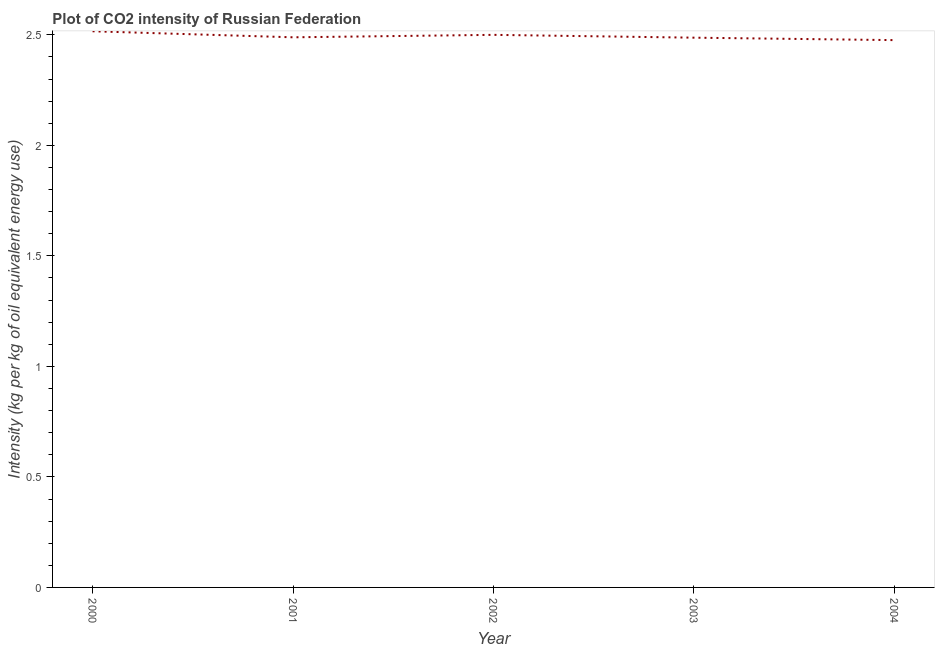What is the co2 intensity in 2003?
Provide a short and direct response. 2.49. Across all years, what is the maximum co2 intensity?
Your response must be concise. 2.52. Across all years, what is the minimum co2 intensity?
Make the answer very short. 2.48. In which year was the co2 intensity maximum?
Your answer should be very brief. 2000. What is the sum of the co2 intensity?
Provide a succinct answer. 12.47. What is the difference between the co2 intensity in 2000 and 2002?
Ensure brevity in your answer.  0.02. What is the average co2 intensity per year?
Keep it short and to the point. 2.49. What is the median co2 intensity?
Your response must be concise. 2.49. What is the ratio of the co2 intensity in 2000 to that in 2004?
Ensure brevity in your answer.  1.02. Is the difference between the co2 intensity in 2002 and 2003 greater than the difference between any two years?
Give a very brief answer. No. What is the difference between the highest and the second highest co2 intensity?
Offer a terse response. 0.02. Is the sum of the co2 intensity in 2002 and 2004 greater than the maximum co2 intensity across all years?
Ensure brevity in your answer.  Yes. What is the difference between the highest and the lowest co2 intensity?
Your answer should be very brief. 0.04. What is the difference between two consecutive major ticks on the Y-axis?
Provide a succinct answer. 0.5. What is the title of the graph?
Your answer should be very brief. Plot of CO2 intensity of Russian Federation. What is the label or title of the X-axis?
Make the answer very short. Year. What is the label or title of the Y-axis?
Provide a succinct answer. Intensity (kg per kg of oil equivalent energy use). What is the Intensity (kg per kg of oil equivalent energy use) in 2000?
Provide a short and direct response. 2.52. What is the Intensity (kg per kg of oil equivalent energy use) in 2001?
Provide a short and direct response. 2.49. What is the Intensity (kg per kg of oil equivalent energy use) of 2002?
Offer a very short reply. 2.5. What is the Intensity (kg per kg of oil equivalent energy use) of 2003?
Your response must be concise. 2.49. What is the Intensity (kg per kg of oil equivalent energy use) of 2004?
Your answer should be compact. 2.48. What is the difference between the Intensity (kg per kg of oil equivalent energy use) in 2000 and 2001?
Provide a succinct answer. 0.03. What is the difference between the Intensity (kg per kg of oil equivalent energy use) in 2000 and 2002?
Offer a terse response. 0.02. What is the difference between the Intensity (kg per kg of oil equivalent energy use) in 2000 and 2003?
Your answer should be compact. 0.03. What is the difference between the Intensity (kg per kg of oil equivalent energy use) in 2000 and 2004?
Offer a very short reply. 0.04. What is the difference between the Intensity (kg per kg of oil equivalent energy use) in 2001 and 2002?
Provide a short and direct response. -0.01. What is the difference between the Intensity (kg per kg of oil equivalent energy use) in 2001 and 2003?
Your response must be concise. 0. What is the difference between the Intensity (kg per kg of oil equivalent energy use) in 2001 and 2004?
Provide a short and direct response. 0.01. What is the difference between the Intensity (kg per kg of oil equivalent energy use) in 2002 and 2003?
Ensure brevity in your answer.  0.01. What is the difference between the Intensity (kg per kg of oil equivalent energy use) in 2002 and 2004?
Your response must be concise. 0.02. What is the difference between the Intensity (kg per kg of oil equivalent energy use) in 2003 and 2004?
Give a very brief answer. 0.01. What is the ratio of the Intensity (kg per kg of oil equivalent energy use) in 2000 to that in 2001?
Your response must be concise. 1.01. What is the ratio of the Intensity (kg per kg of oil equivalent energy use) in 2000 to that in 2002?
Provide a short and direct response. 1.01. What is the ratio of the Intensity (kg per kg of oil equivalent energy use) in 2000 to that in 2003?
Your answer should be compact. 1.01. What is the ratio of the Intensity (kg per kg of oil equivalent energy use) in 2000 to that in 2004?
Provide a short and direct response. 1.02. What is the ratio of the Intensity (kg per kg of oil equivalent energy use) in 2001 to that in 2004?
Your response must be concise. 1. What is the ratio of the Intensity (kg per kg of oil equivalent energy use) in 2002 to that in 2004?
Provide a short and direct response. 1.01. 